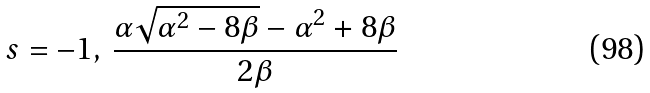Convert formula to latex. <formula><loc_0><loc_0><loc_500><loc_500>s = - 1 , \, \frac { \alpha \sqrt { \alpha ^ { 2 } - 8 \beta } - \alpha ^ { 2 } + 8 \beta } { 2 \beta }</formula> 